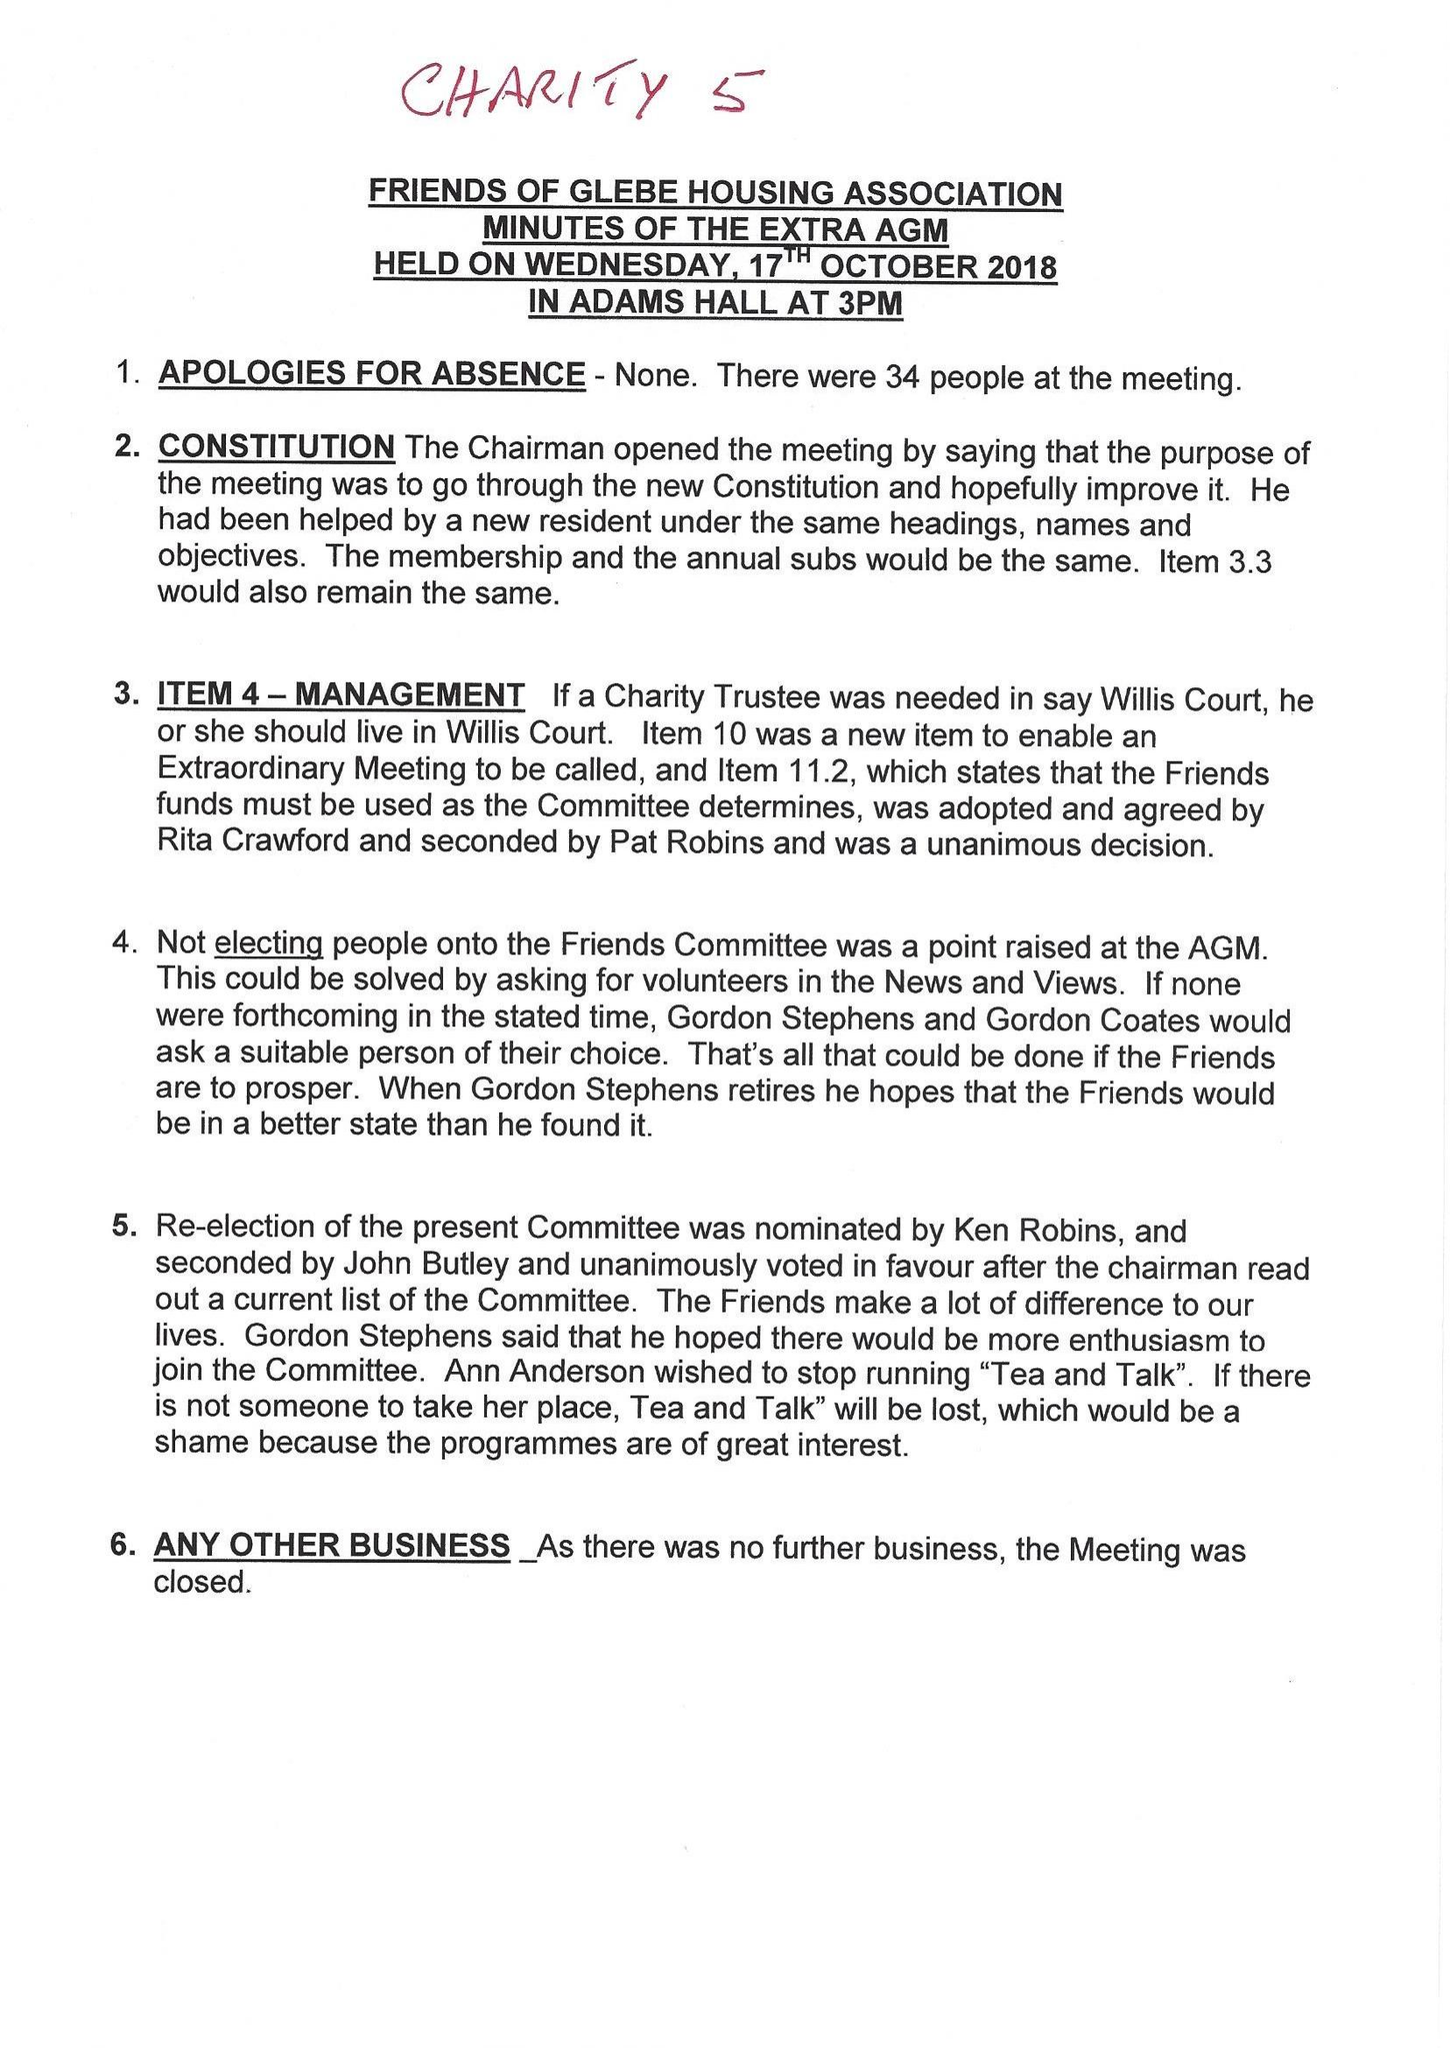What is the value for the charity_name?
Answer the question using a single word or phrase. The Friends Of Glebe Housing Association 